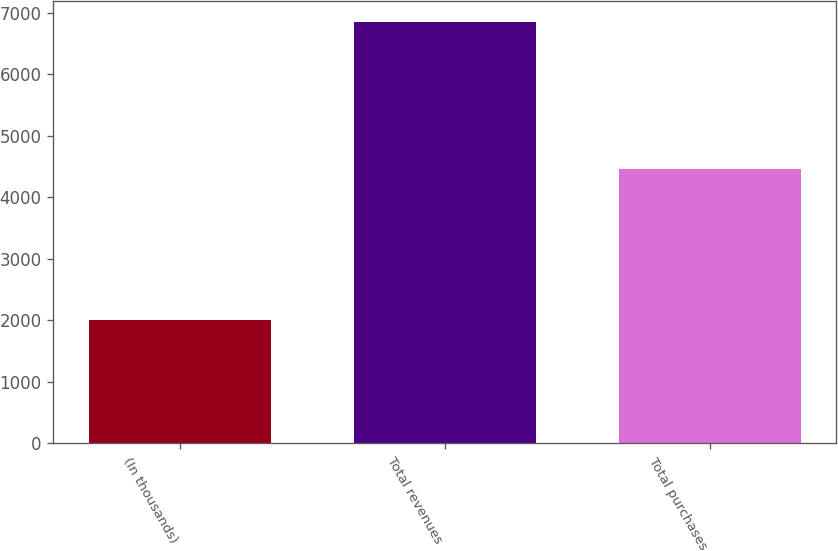Convert chart to OTSL. <chart><loc_0><loc_0><loc_500><loc_500><bar_chart><fcel>(In thousands)<fcel>Total revenues<fcel>Total purchases<nl><fcel>2013<fcel>6854<fcel>4460<nl></chart> 